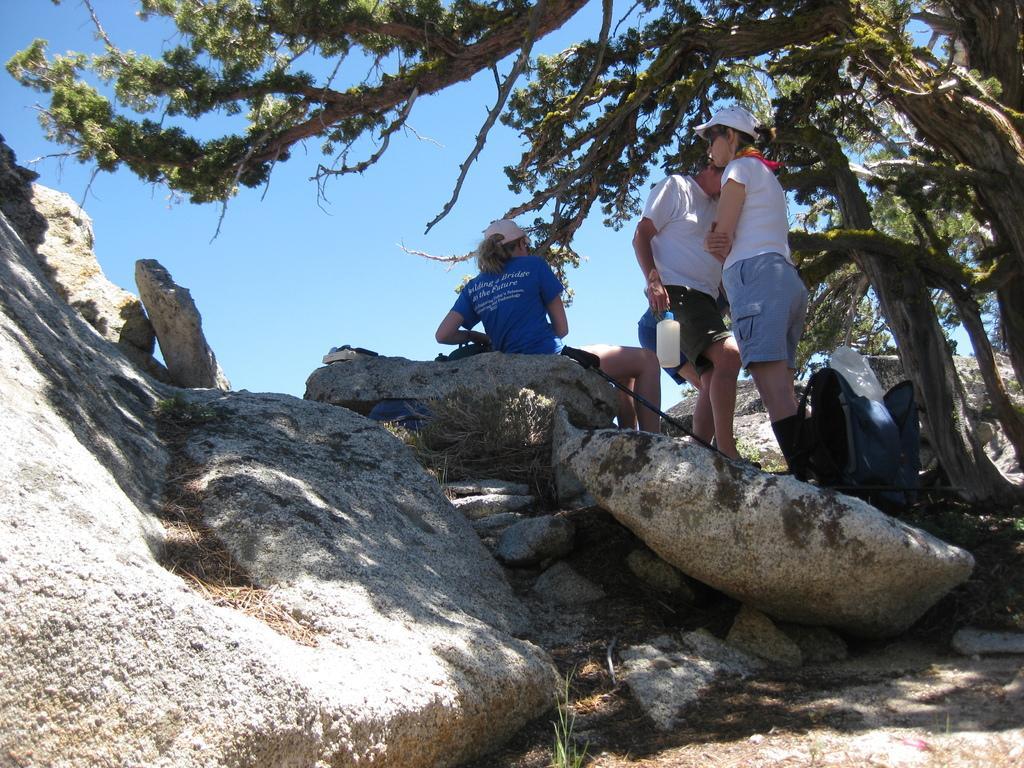In one or two sentences, can you explain what this image depicts? In the image there are few people walking on rock, on the right side there are trees and above its sky. 